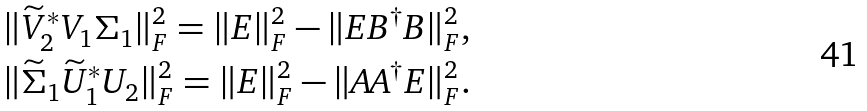<formula> <loc_0><loc_0><loc_500><loc_500>& \| \widetilde { V } _ { 2 } ^ { \ast } V _ { 1 } \Sigma _ { 1 } \| _ { F } ^ { 2 } = \| E \| _ { F } ^ { 2 } - \| E B ^ { \dagger } B \| _ { F } ^ { 2 } , \\ & \| \widetilde { \Sigma } _ { 1 } \widetilde { U } _ { 1 } ^ { \ast } U _ { 2 } \| _ { F } ^ { 2 } = \| E \| _ { F } ^ { 2 } - \| A A ^ { \dagger } E \| _ { F } ^ { 2 } .</formula> 